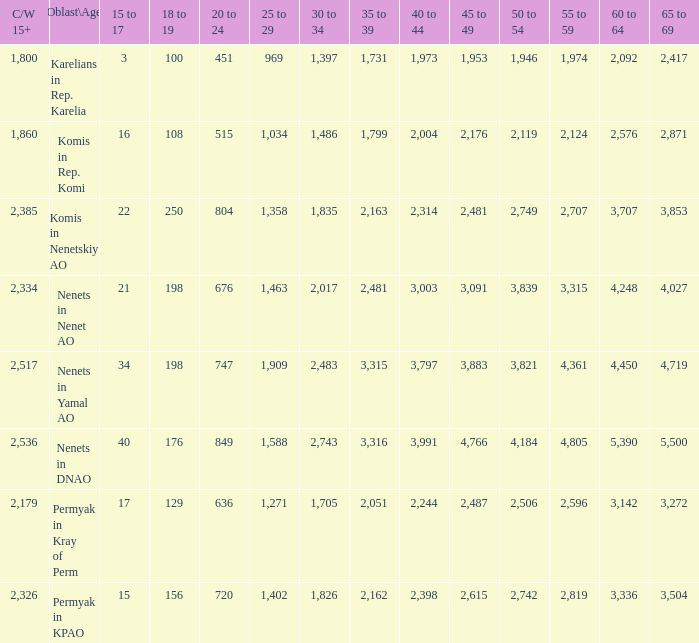When the oblast\age is nenets in yamal ao and the 45 to 49 age group exceeds 3,883, what is the sum for the 60 to 64 age group? None. 